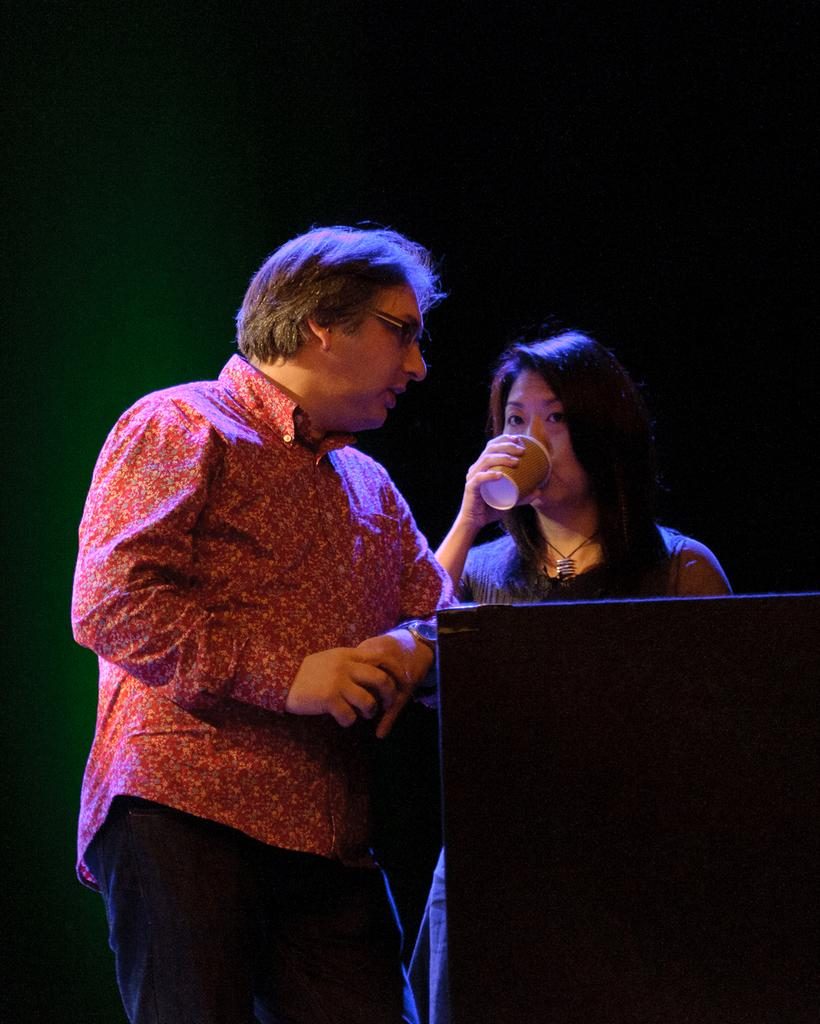What is the main subject of the image? There is a man standing in the image. What is the man wearing? The man is wearing a shirt and trousers. Who is standing beside the man? There is a woman standing beside the man. What is the woman doing in the image? The woman is holding a glass and appears to be drinking from it. What type of quill is the man using to write a letter in the image? There is no quill or letter-writing activity depicted in the image. Can you tell me the color of the box that the woman is holding in the image? There is no box present in the image; the woman is holding a glass and drinking from it. 